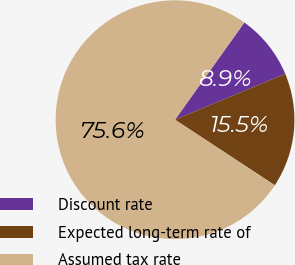Convert chart to OTSL. <chart><loc_0><loc_0><loc_500><loc_500><pie_chart><fcel>Discount rate<fcel>Expected long-term rate of<fcel>Assumed tax rate<nl><fcel>8.86%<fcel>15.53%<fcel>75.61%<nl></chart> 